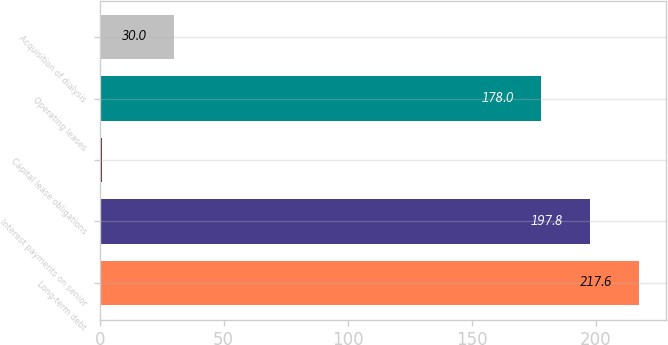Convert chart. <chart><loc_0><loc_0><loc_500><loc_500><bar_chart><fcel>Long-term debt<fcel>Interest payments on senior<fcel>Capital lease obligations<fcel>Operating leases<fcel>Acquisition of dialysis<nl><fcel>217.6<fcel>197.8<fcel>1<fcel>178<fcel>30<nl></chart> 